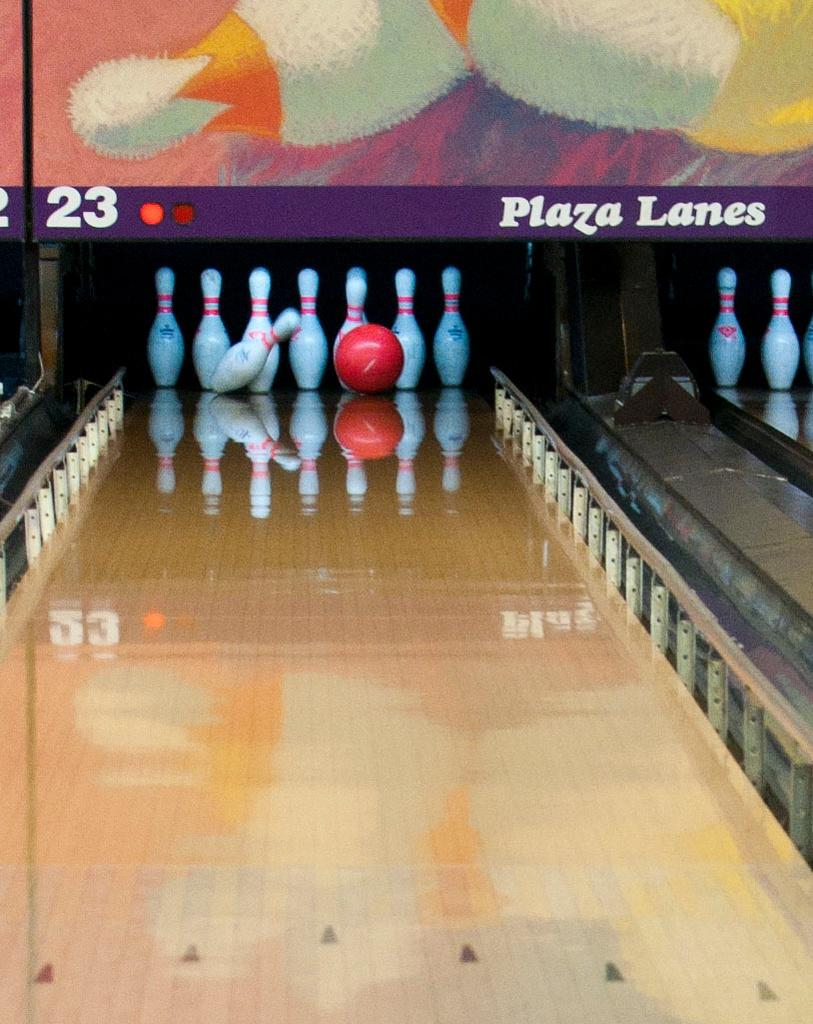What is the main object in the image? There is a bowling ball in the image. What is the bowling ball positioned near? There is a group of pins in the image. What type of surface are the bowling ball and pins placed on? The bowling ball and pins are placed on a wood surface. What can be seen in the background of the image? There is a signboard with text in the background of the image. What type of liquid is being poured from the ring in the image? There is no ring or liquid present in the image. 